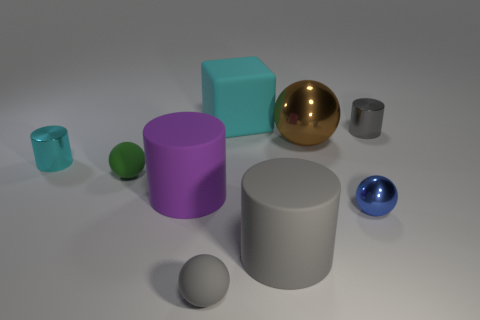Subtract 1 spheres. How many spheres are left? 3 Add 1 large blue rubber spheres. How many objects exist? 10 Subtract all balls. How many objects are left? 5 Add 9 small brown metal balls. How many small brown metal balls exist? 9 Subtract 1 purple cylinders. How many objects are left? 8 Subtract all gray rubber blocks. Subtract all balls. How many objects are left? 5 Add 3 tiny gray objects. How many tiny gray objects are left? 5 